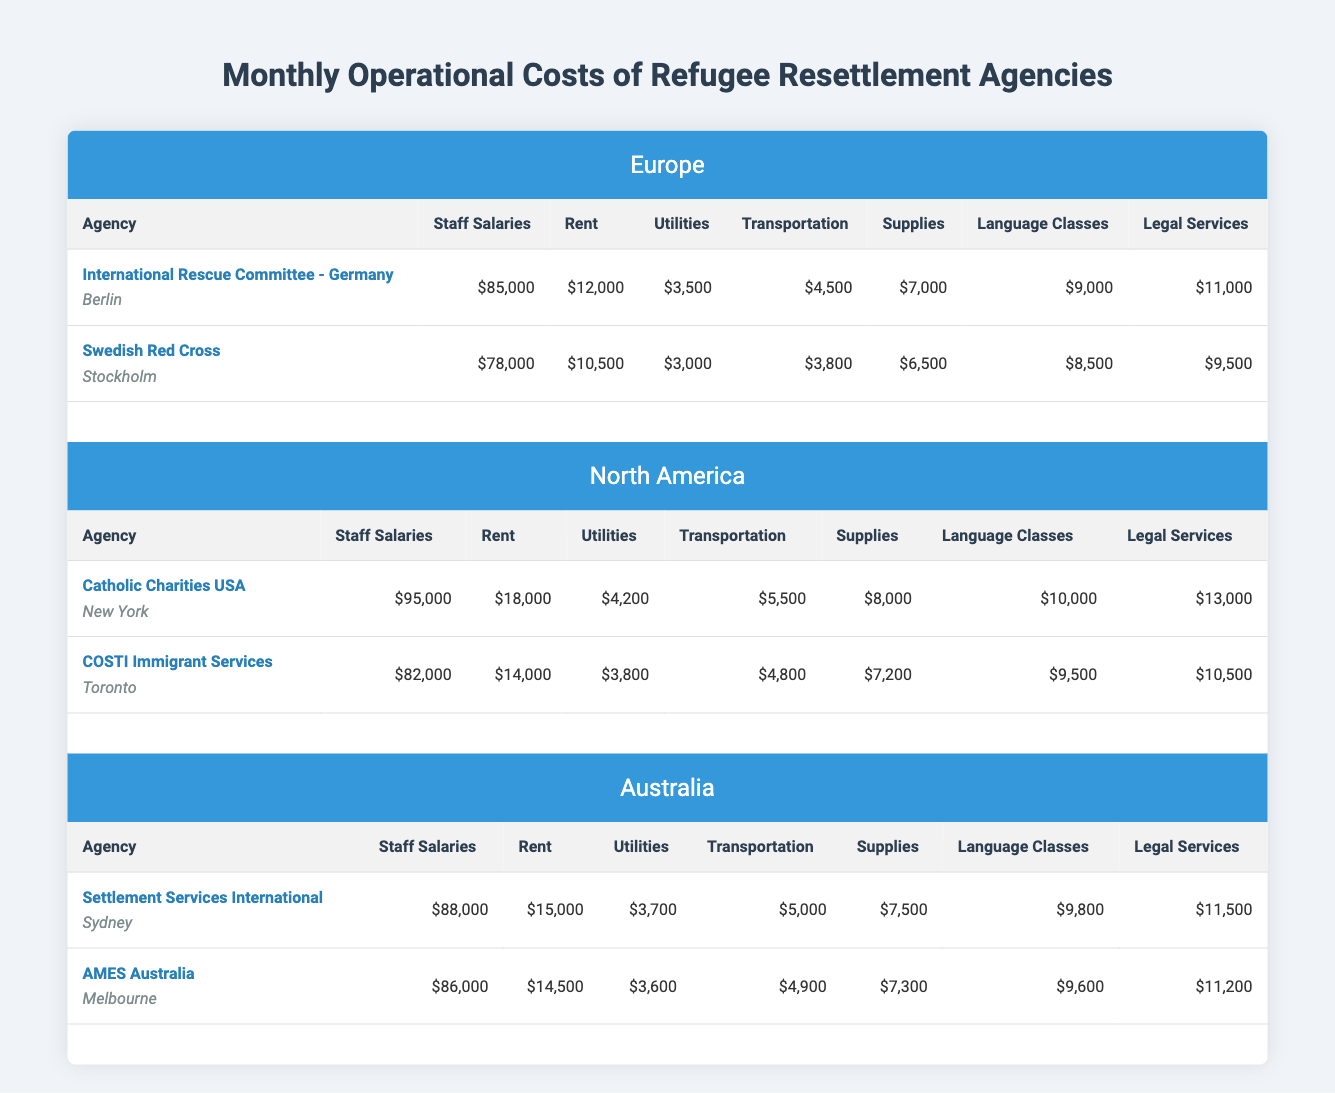What are the total monthly costs for International Rescue Committee - Germany? To calculate the total monthly costs for this agency, we sum all the costs provided: staff salaries ($85,000) + rent ($12,000) + utilities ($3,500) + transportation ($4,500) + supplies ($7,000) + language classes ($9,000) + legal services ($11,000). This gives us a total of $132,000.
Answer: $132,000 Which agency has the highest staff salaries? By comparing the staff salaries of all agencies listed, International Rescue Committee - Germany has the highest salary at $85,000, surpassing the others.
Answer: International Rescue Committee - Germany What is the total monthly cost for legal services across all agencies in North America? The legal services costs for the two agencies in North America are: Catholic Charities USA ($13,000) and COSTI Immigrant Services ($10,500). Adding these values: $13,000 + $10,500 = $23,500.
Answer: $23,500 Is the sum of transportation costs higher in Europe than in Australia? In Europe, the total transportation costs are $4,500 (International Rescue Committee - Germany) + $3,800 (Swedish Red Cross) = $8,300. In Australia, the total is $5,000 (Settlement Services International) + $4,900 (AMES Australia) = $9,900. Since $8,300 is less than $9,900, the statement is false.
Answer: No What is the average monthly cost for rent among the agencies in Australia? There are two agencies in Australia with the following rent costs: Settlement Services International has $15,000, and AMES Australia has $14,500. To find the average, we first sum them: $15,000 + $14,500 = $29,500 and then divide by 2 (the number of agencies): $29,500 / 2 = $14,750.
Answer: $14,750 